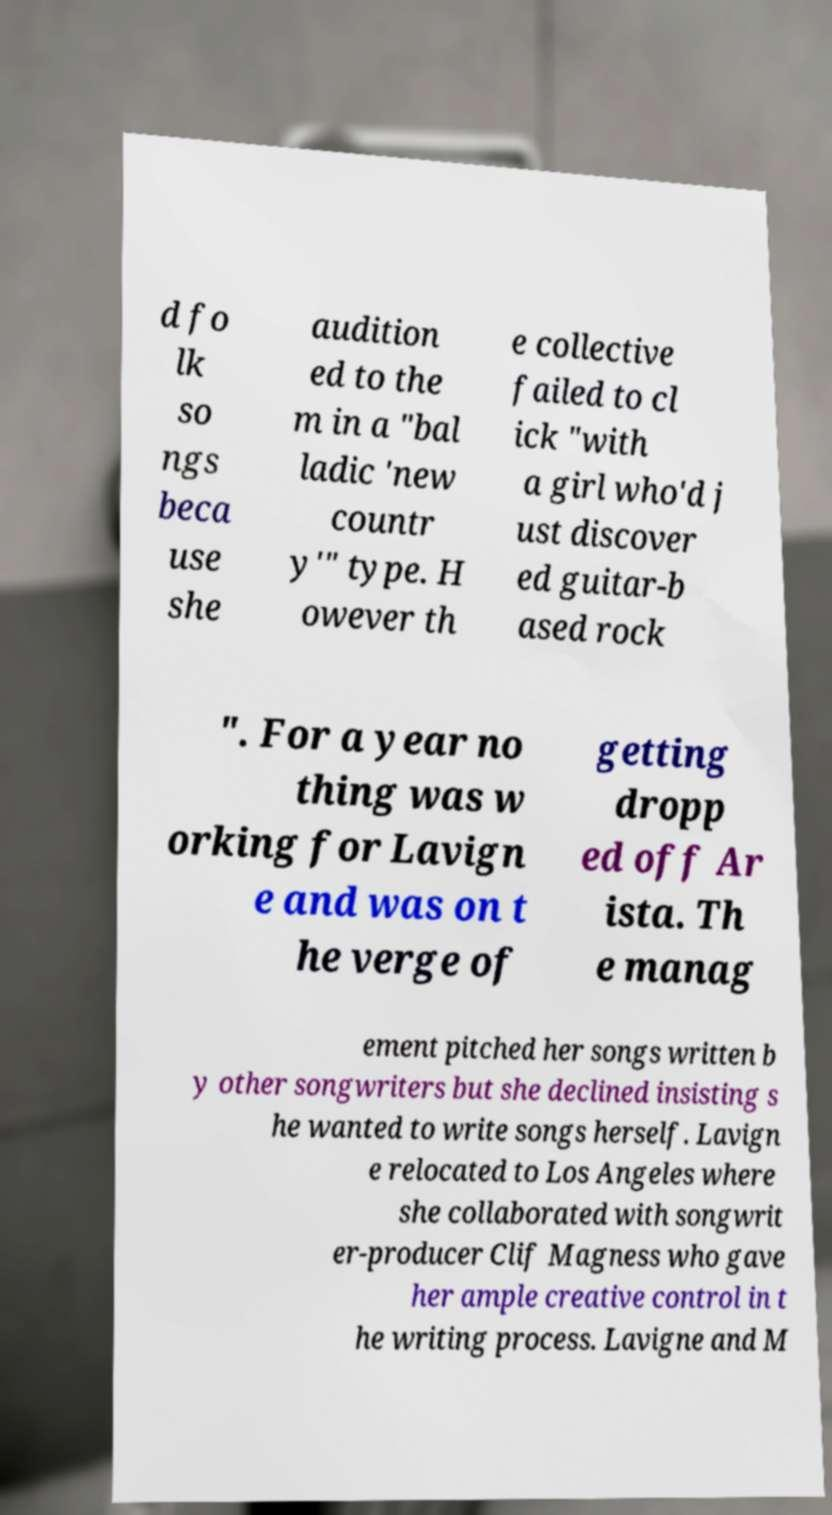Could you extract and type out the text from this image? d fo lk so ngs beca use she audition ed to the m in a "bal ladic 'new countr y'" type. H owever th e collective failed to cl ick "with a girl who'd j ust discover ed guitar-b ased rock ". For a year no thing was w orking for Lavign e and was on t he verge of getting dropp ed off Ar ista. Th e manag ement pitched her songs written b y other songwriters but she declined insisting s he wanted to write songs herself. Lavign e relocated to Los Angeles where she collaborated with songwrit er-producer Clif Magness who gave her ample creative control in t he writing process. Lavigne and M 